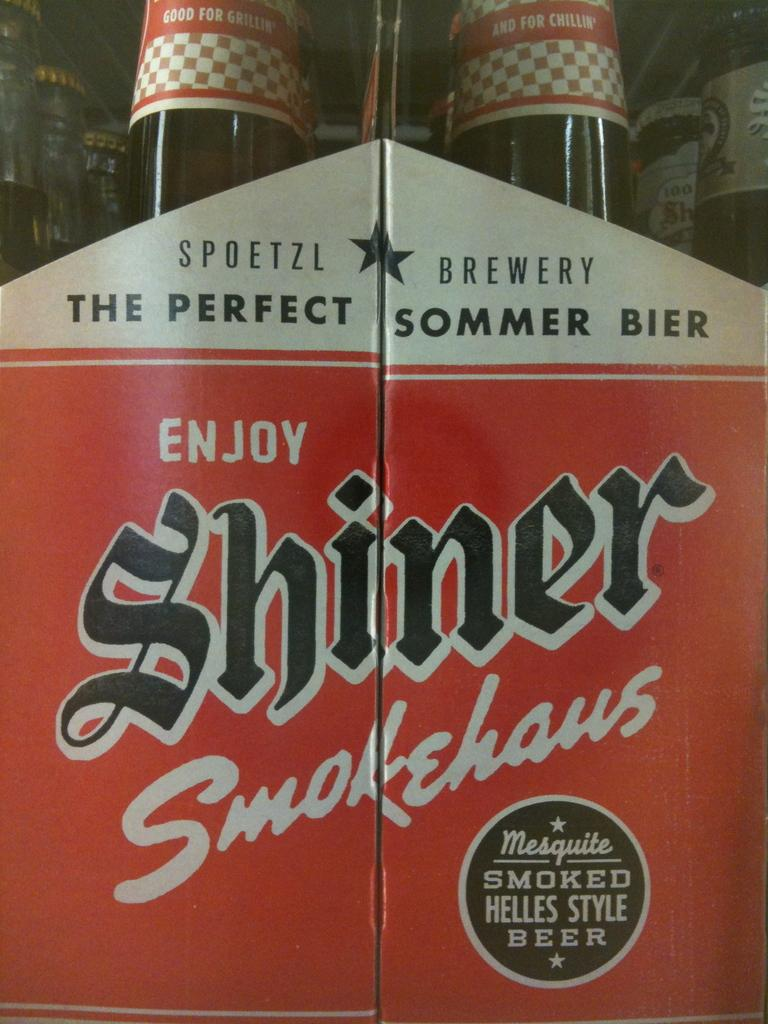Provide a one-sentence caption for the provided image. The red and white packaging for Shiner Smokehaus craft beer. 